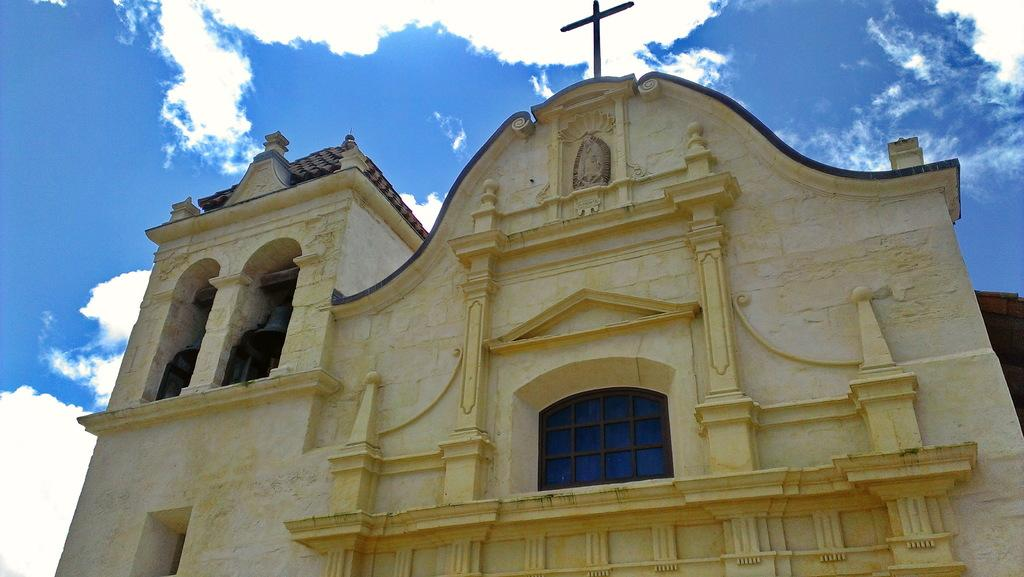What type of building is depicted in the image? The image shows a yellow Church building. What feature can be seen at the front of the building? There is a glass window in the front of the building. What religious symbol is present on the top of the building? There is a cross mark on the top of the building. What can be seen above the building in the image? The sky is visible above the building. What is the condition of the sky in the image? Clouds are present in the sky. How many times does the face of the achiever appear in the image? There is no face or achiever present in the image; it features a yellow Church building with a glass window, a cross mark, and clouds in the sky. 